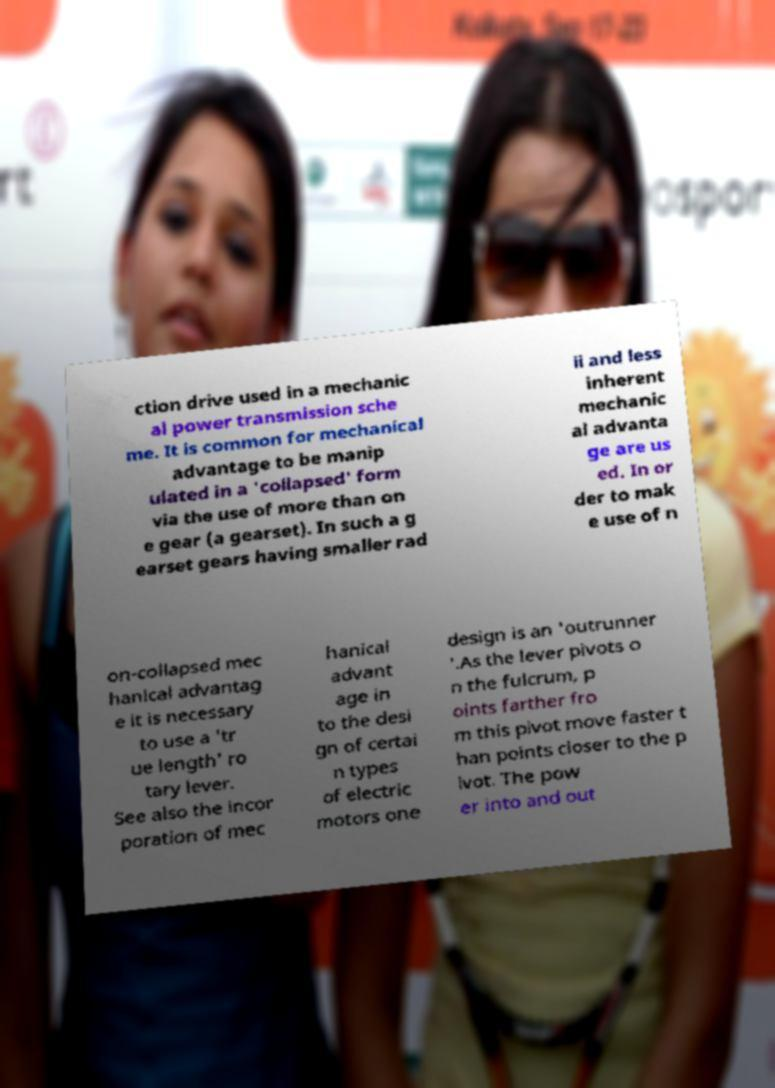Could you extract and type out the text from this image? ction drive used in a mechanic al power transmission sche me. It is common for mechanical advantage to be manip ulated in a 'collapsed' form via the use of more than on e gear (a gearset). In such a g earset gears having smaller rad ii and less inherent mechanic al advanta ge are us ed. In or der to mak e use of n on-collapsed mec hanical advantag e it is necessary to use a 'tr ue length' ro tary lever. See also the incor poration of mec hanical advant age in to the desi gn of certai n types of electric motors one design is an 'outrunner '.As the lever pivots o n the fulcrum, p oints farther fro m this pivot move faster t han points closer to the p ivot. The pow er into and out 